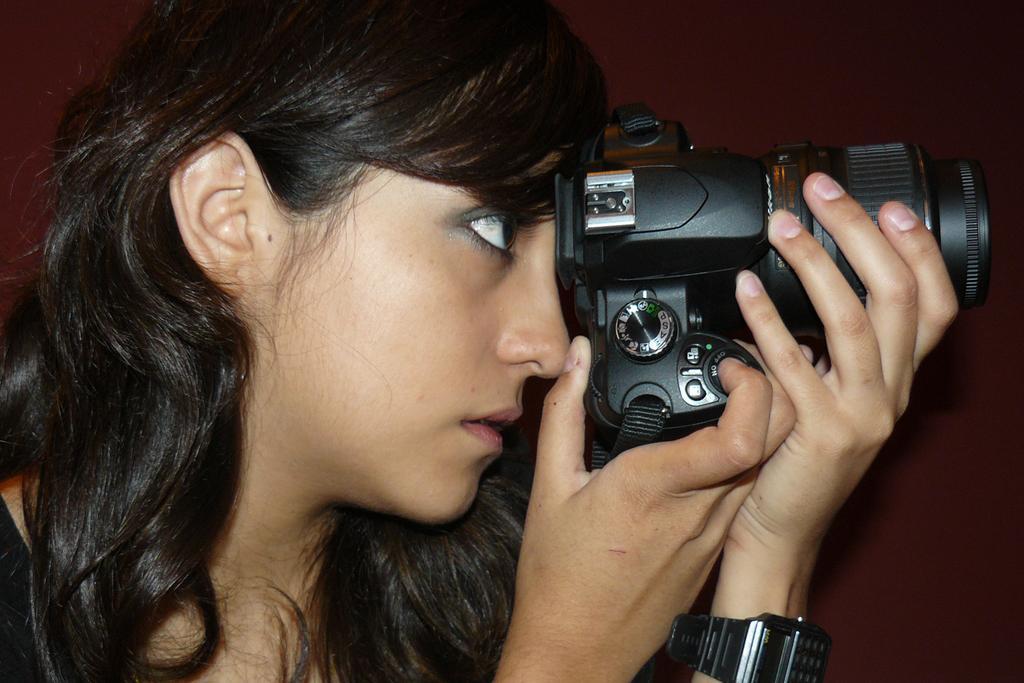How would you summarize this image in a sentence or two? In this picture I can see a woman is holding a camera. The woman is wearing a watch in the hand. 